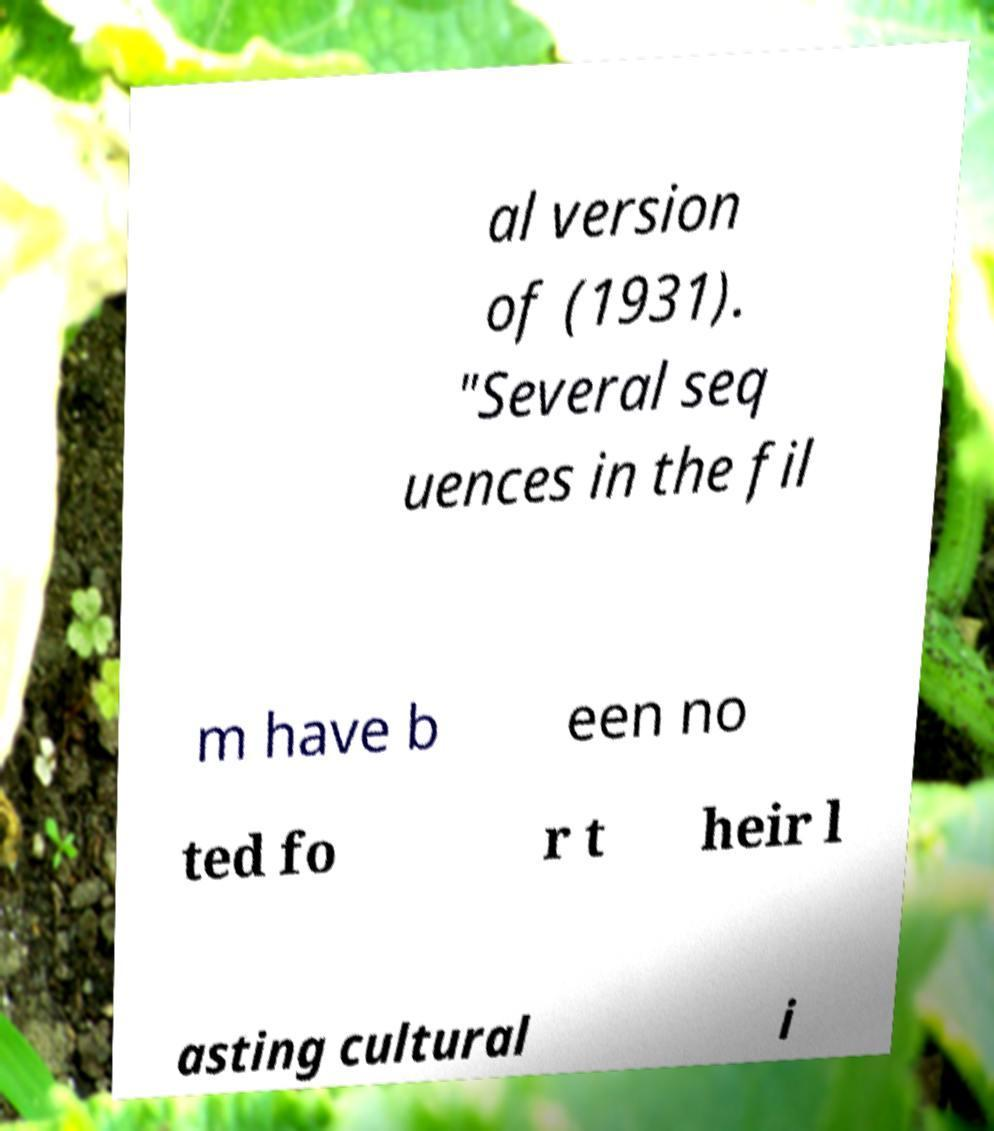Can you read and provide the text displayed in the image?This photo seems to have some interesting text. Can you extract and type it out for me? al version of (1931). "Several seq uences in the fil m have b een no ted fo r t heir l asting cultural i 